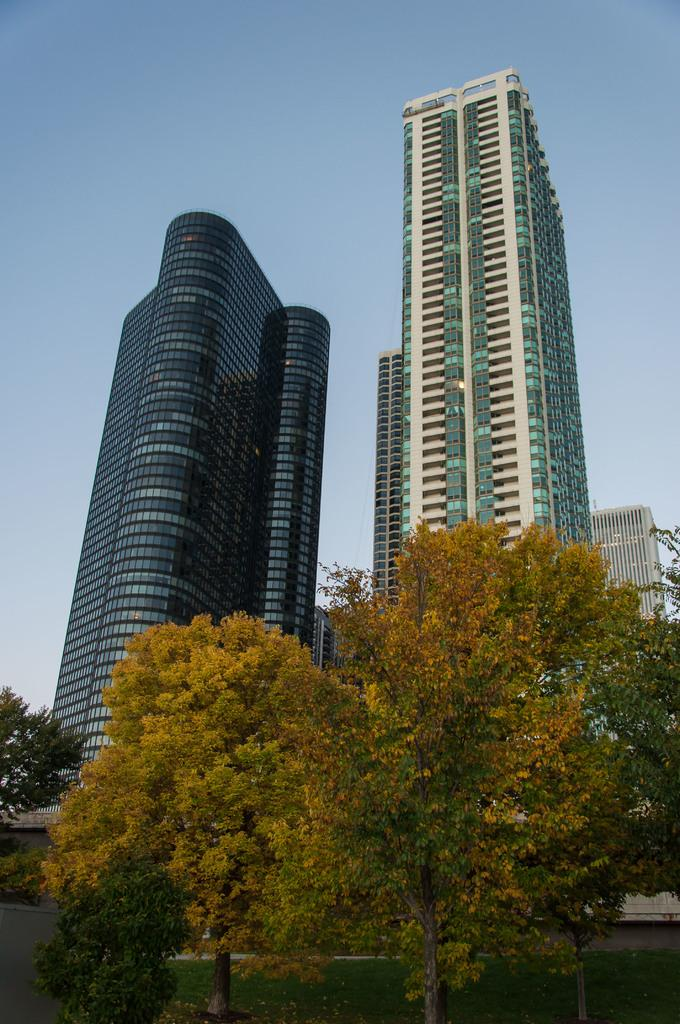What type of vegetation is visible in the image? There are trees in front of the image. What structures can be seen behind the trees? There are buildings behind the trees. What is visible at the top of the image? The sky is visible at the top of the image. What shape is the belief system depicted in the image? There is no belief system depicted in the image; it features trees, buildings, and the sky. How does the adjustment of the camera angle affect the visibility of the trees in the image? The provided facts do not mention any camera adjustments, so it is not possible to determine how they would affect the visibility of the trees in the image. 